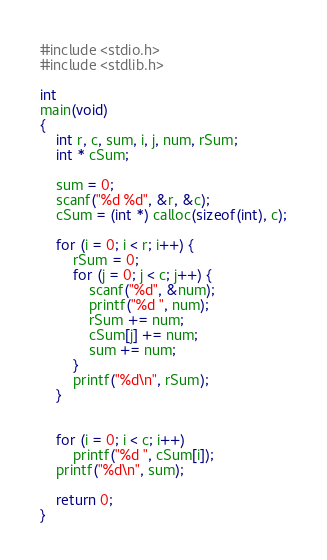Convert code to text. <code><loc_0><loc_0><loc_500><loc_500><_C_>#include <stdio.h>
#include <stdlib.h>

int
main(void)
{
    int r, c, sum, i, j, num, rSum;
    int * cSum;

    sum = 0;
    scanf("%d %d", &r, &c);
    cSum = (int *) calloc(sizeof(int), c);

    for (i = 0; i < r; i++) {
        rSum = 0;
        for (j = 0; j < c; j++) {
            scanf("%d", &num);
            printf("%d ", num);
            rSum += num;
            cSum[j] += num;
            sum += num;
        }
        printf("%d\n", rSum);
    }


    for (i = 0; i < c; i++)
        printf("%d ", cSum[i]);
    printf("%d\n", sum);

    return 0;
}
</code> 